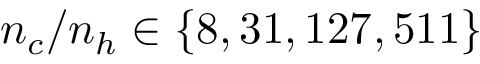Convert formula to latex. <formula><loc_0><loc_0><loc_500><loc_500>n _ { c } / n _ { h } \in \{ 8 , 3 1 , 1 2 7 , 5 1 1 \}</formula> 